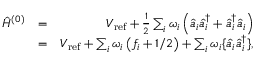Convert formula to latex. <formula><loc_0><loc_0><loc_500><loc_500>\begin{array} { r l r } { \hat { H } ^ { ( 0 ) } } & { = } & { V _ { r e f } + \frac { 1 } { 2 } \sum _ { i } \omega _ { i } \left ( \hat { a } _ { i } \hat { a } _ { i } ^ { \dagger } + \hat { a } _ { i } ^ { \dagger } \hat { a } _ { i } \right ) } \\ & { = } & { V _ { r e f } + \sum _ { i } { { \omega } _ { i } } \left ( f _ { i } + { 1 } / { 2 } \right ) + \sum _ { i } { { \omega } _ { i } } \{ \hat { a } _ { i } \hat { a } _ { i } ^ { \dagger } \} , } \end{array}</formula> 